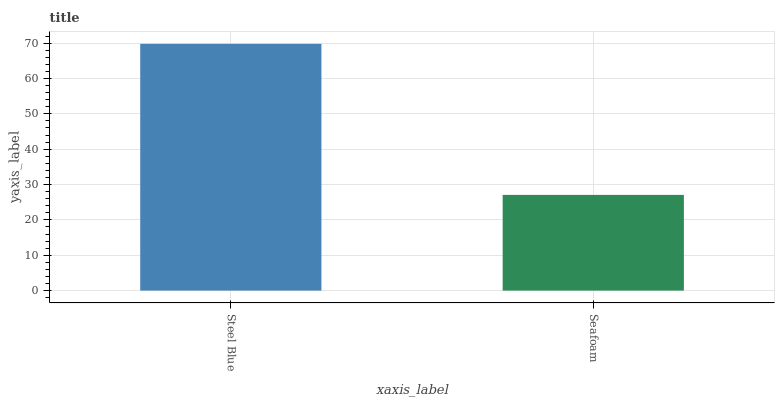Is Seafoam the minimum?
Answer yes or no. Yes. Is Steel Blue the maximum?
Answer yes or no. Yes. Is Seafoam the maximum?
Answer yes or no. No. Is Steel Blue greater than Seafoam?
Answer yes or no. Yes. Is Seafoam less than Steel Blue?
Answer yes or no. Yes. Is Seafoam greater than Steel Blue?
Answer yes or no. No. Is Steel Blue less than Seafoam?
Answer yes or no. No. Is Steel Blue the high median?
Answer yes or no. Yes. Is Seafoam the low median?
Answer yes or no. Yes. Is Seafoam the high median?
Answer yes or no. No. Is Steel Blue the low median?
Answer yes or no. No. 